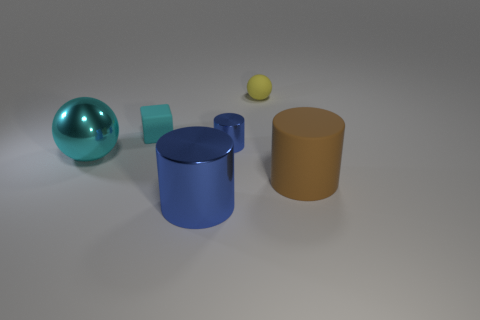Subtract all brown cylinders. Subtract all blue balls. How many cylinders are left? 2 Add 3 large matte cylinders. How many objects exist? 9 Subtract all spheres. How many objects are left? 4 Subtract 0 brown spheres. How many objects are left? 6 Subtract all metal things. Subtract all cyan objects. How many objects are left? 1 Add 2 brown rubber things. How many brown rubber things are left? 3 Add 2 blue things. How many blue things exist? 4 